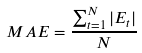Convert formula to latex. <formula><loc_0><loc_0><loc_500><loc_500>M A E = \frac { \sum _ { t = 1 } ^ { N } | E _ { t } | } { N }</formula> 